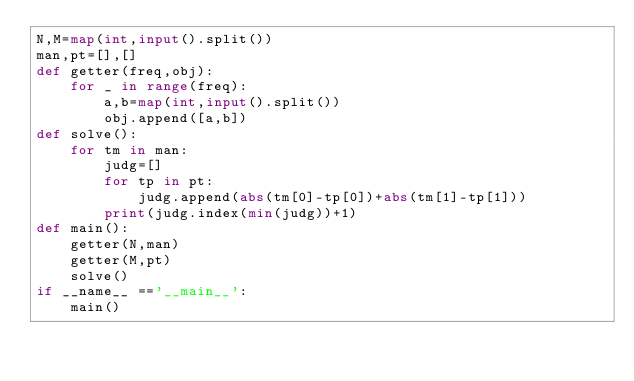Convert code to text. <code><loc_0><loc_0><loc_500><loc_500><_Python_>N,M=map(int,input().split())
man,pt=[],[]
def getter(freq,obj):
    for _ in range(freq):
        a,b=map(int,input().split())
        obj.append([a,b])
def solve():
    for tm in man:
        judg=[]
        for tp in pt:
            judg.append(abs(tm[0]-tp[0])+abs(tm[1]-tp[1]))
        print(judg.index(min(judg))+1)
def main():
    getter(N,man)
    getter(M,pt)
    solve()
if __name__ =='__main__':
    main()</code> 